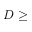<formula> <loc_0><loc_0><loc_500><loc_500>D \geq</formula> 